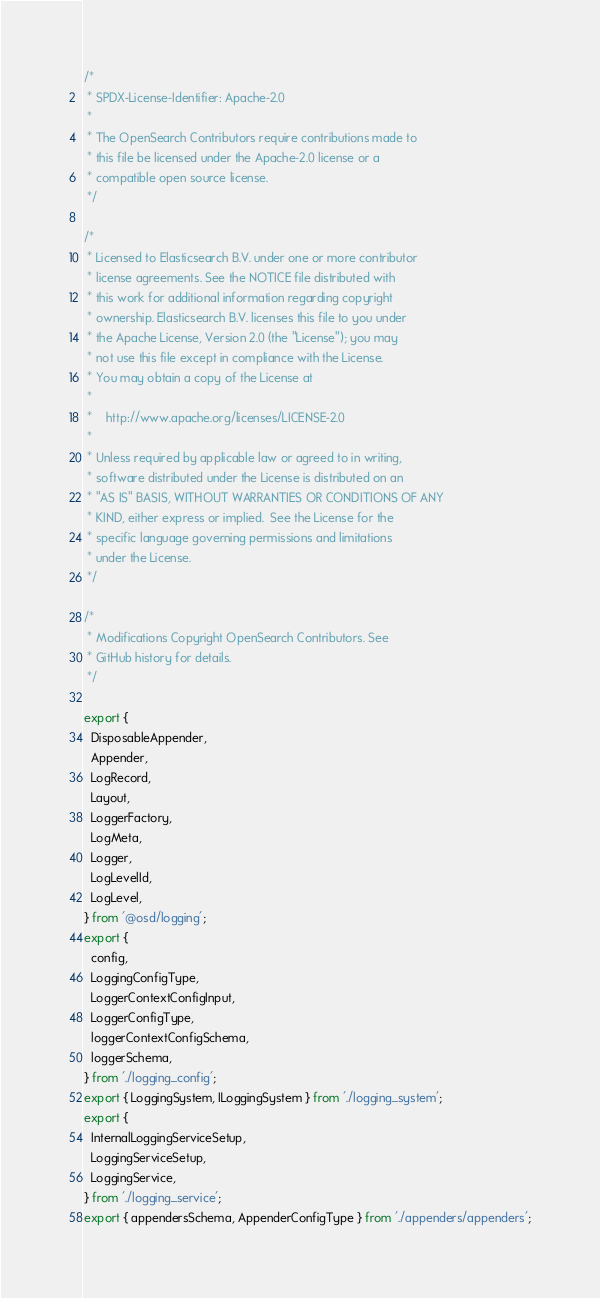Convert code to text. <code><loc_0><loc_0><loc_500><loc_500><_TypeScript_>/*
 * SPDX-License-Identifier: Apache-2.0
 *
 * The OpenSearch Contributors require contributions made to
 * this file be licensed under the Apache-2.0 license or a
 * compatible open source license.
 */

/*
 * Licensed to Elasticsearch B.V. under one or more contributor
 * license agreements. See the NOTICE file distributed with
 * this work for additional information regarding copyright
 * ownership. Elasticsearch B.V. licenses this file to you under
 * the Apache License, Version 2.0 (the "License"); you may
 * not use this file except in compliance with the License.
 * You may obtain a copy of the License at
 *
 *    http://www.apache.org/licenses/LICENSE-2.0
 *
 * Unless required by applicable law or agreed to in writing,
 * software distributed under the License is distributed on an
 * "AS IS" BASIS, WITHOUT WARRANTIES OR CONDITIONS OF ANY
 * KIND, either express or implied.  See the License for the
 * specific language governing permissions and limitations
 * under the License.
 */

/*
 * Modifications Copyright OpenSearch Contributors. See
 * GitHub history for details.
 */

export {
  DisposableAppender,
  Appender,
  LogRecord,
  Layout,
  LoggerFactory,
  LogMeta,
  Logger,
  LogLevelId,
  LogLevel,
} from '@osd/logging';
export {
  config,
  LoggingConfigType,
  LoggerContextConfigInput,
  LoggerConfigType,
  loggerContextConfigSchema,
  loggerSchema,
} from './logging_config';
export { LoggingSystem, ILoggingSystem } from './logging_system';
export {
  InternalLoggingServiceSetup,
  LoggingServiceSetup,
  LoggingService,
} from './logging_service';
export { appendersSchema, AppenderConfigType } from './appenders/appenders';
</code> 